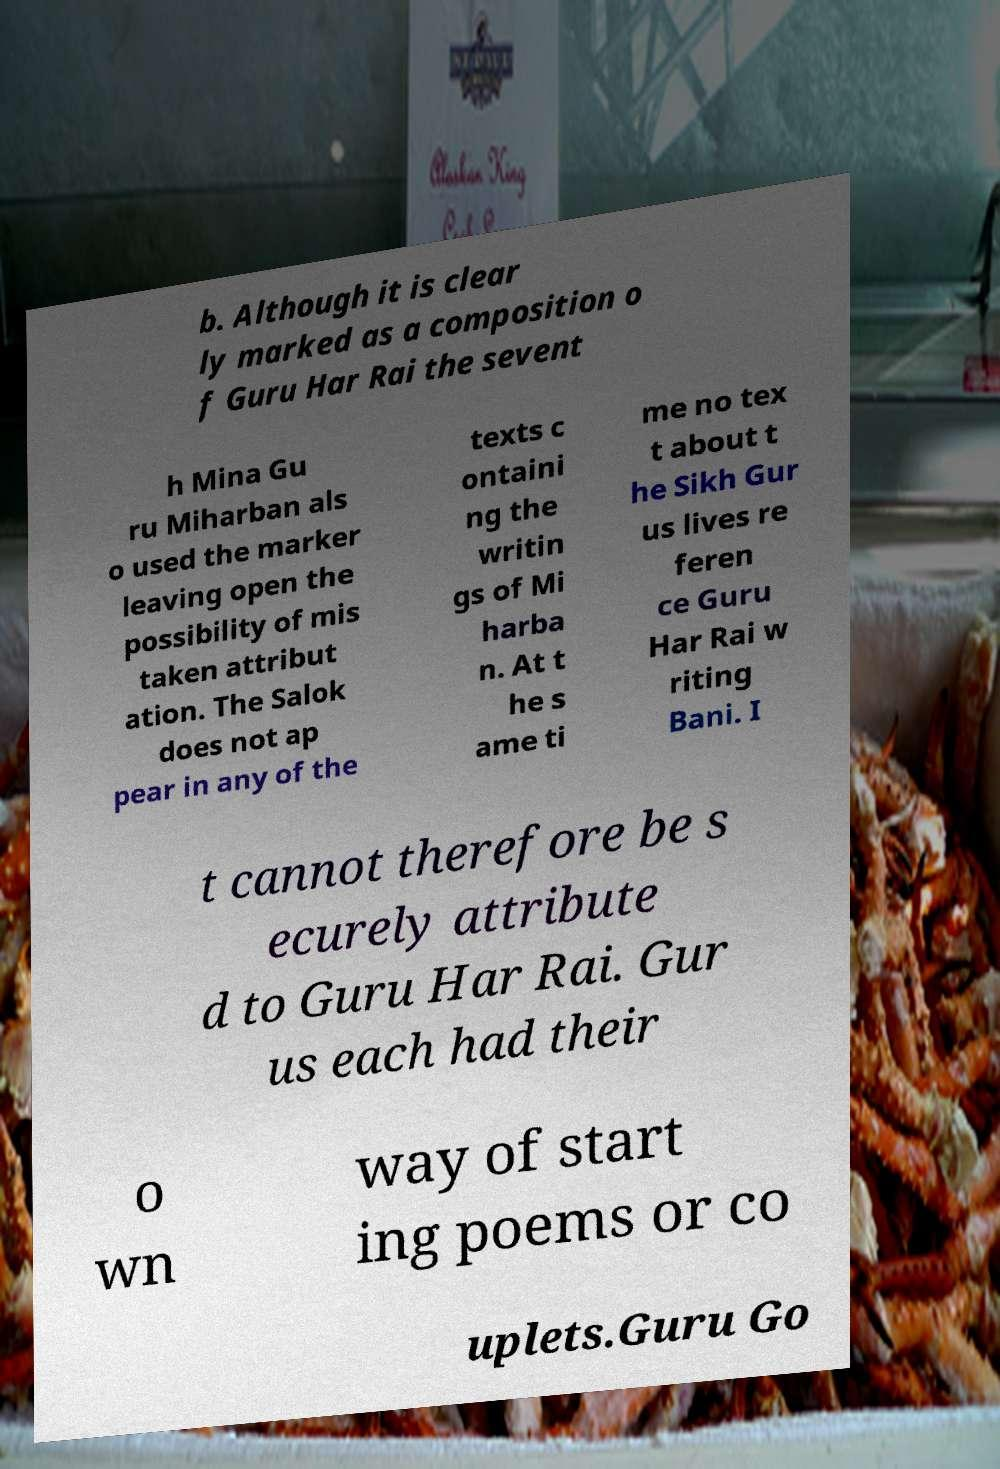Could you extract and type out the text from this image? b. Although it is clear ly marked as a composition o f Guru Har Rai the sevent h Mina Gu ru Miharban als o used the marker leaving open the possibility of mis taken attribut ation. The Salok does not ap pear in any of the texts c ontaini ng the writin gs of Mi harba n. At t he s ame ti me no tex t about t he Sikh Gur us lives re feren ce Guru Har Rai w riting Bani. I t cannot therefore be s ecurely attribute d to Guru Har Rai. Gur us each had their o wn way of start ing poems or co uplets.Guru Go 